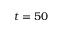Convert formula to latex. <formula><loc_0><loc_0><loc_500><loc_500>t = 5 0</formula> 